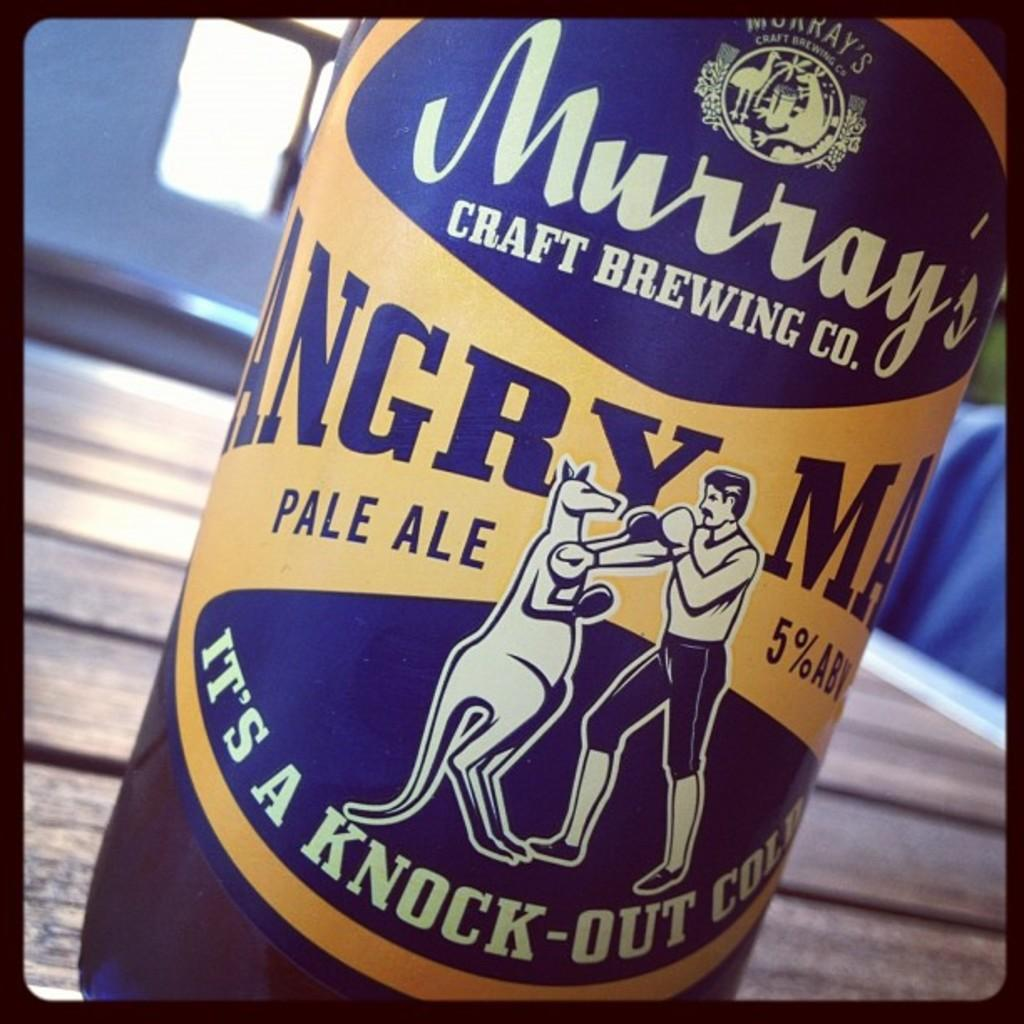Provide a one-sentence caption for the provided image. Murray's Craft Brewing Company that says Angry Man Pale Ale 5% ABV, Its a Knock-Out Cold. 